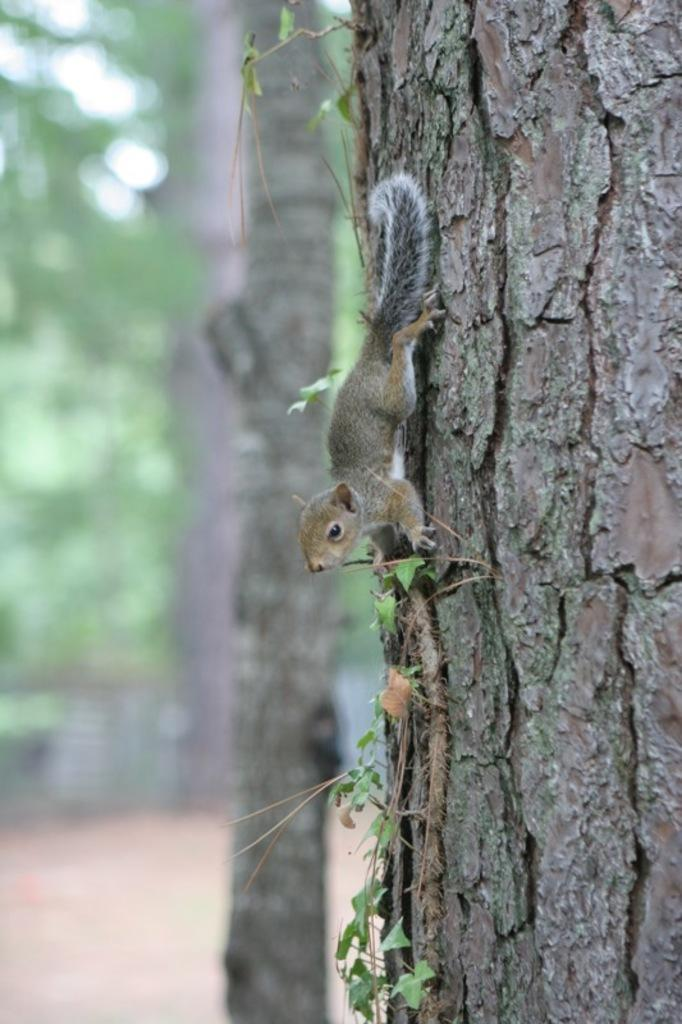What type of animal is in the image? There is a squirrel in the image. Where is the squirrel located? The squirrel is on the bark of a tree. What else can be seen in the image besides the squirrel? There are leaves visible in the image. What is visible in the background of the image? There are trees visible in the background of the image. Can you see any details of the dock in the image? There is no dock present in the image. What type of game is the squirrel playing in the image? The image does not depict the squirrel playing any game; it is simply sitting on the bark of a tree. 